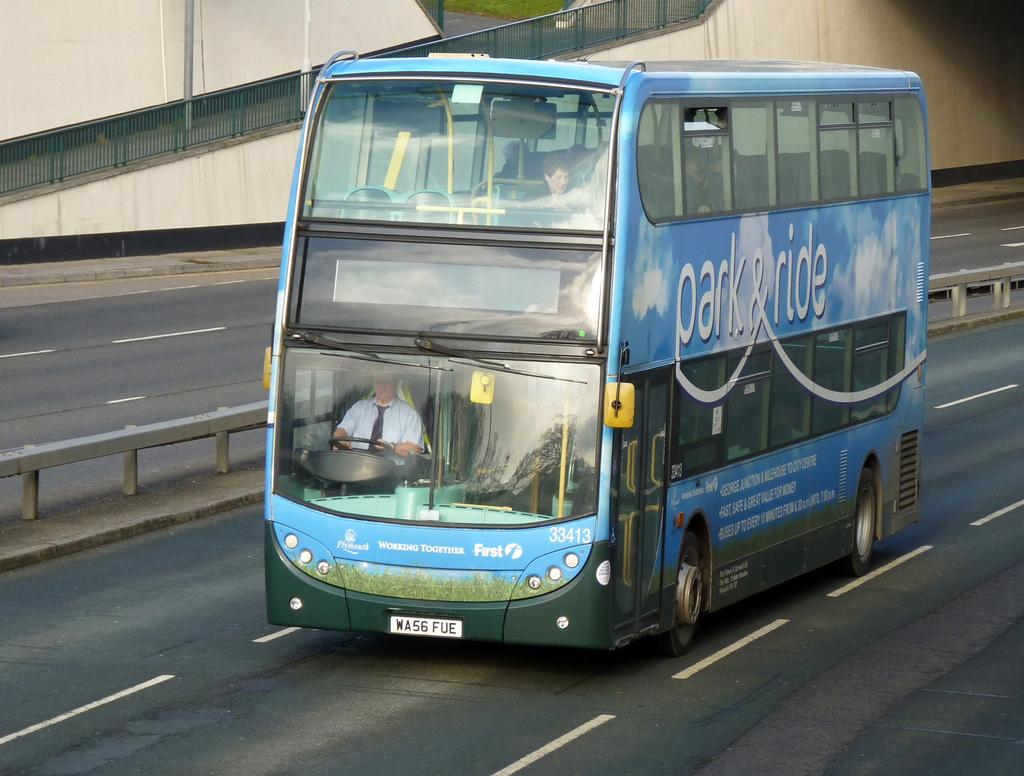What is the main subject of the image? There is a vehicle on the road in the image. Can you describe the occupants of the vehicle? There are people inside the vehicle. What can be seen in the background of the image? There is a fence and a wall in the background of the image, along with other objects. Where is the crib located in the image? There is no crib present in the image. Can you tell me how many faucets are visible in the image? There are no faucets visible in the image. 